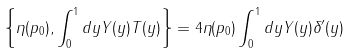Convert formula to latex. <formula><loc_0><loc_0><loc_500><loc_500>\left \{ \eta ( p _ { 0 } ) , \int _ { 0 } ^ { 1 } d y Y ( y ) T ( y ) \right \} = 4 \eta ( p _ { 0 } ) \int _ { 0 } ^ { 1 } d y Y ( y ) \delta ^ { \prime } ( y )</formula> 